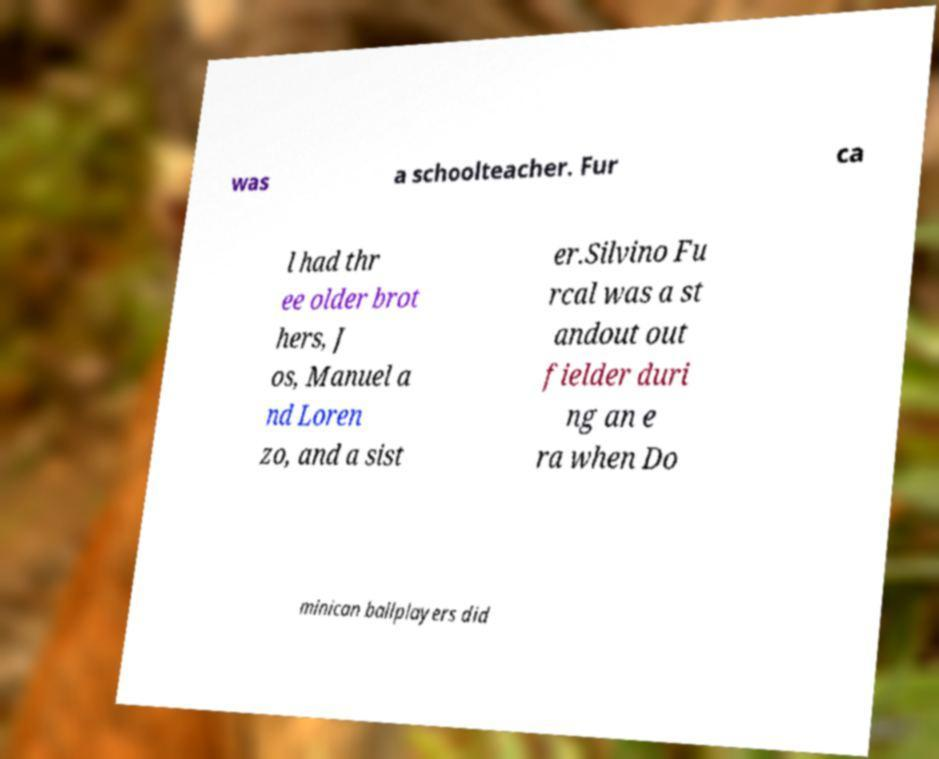Can you read and provide the text displayed in the image?This photo seems to have some interesting text. Can you extract and type it out for me? was a schoolteacher. Fur ca l had thr ee older brot hers, J os, Manuel a nd Loren zo, and a sist er.Silvino Fu rcal was a st andout out fielder duri ng an e ra when Do minican ballplayers did 